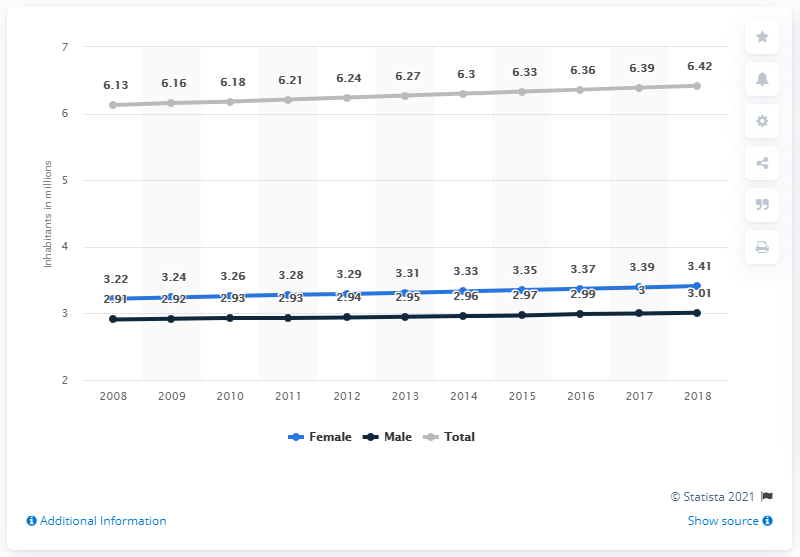How many men lived in El Salvador in 2018?
 3.01 